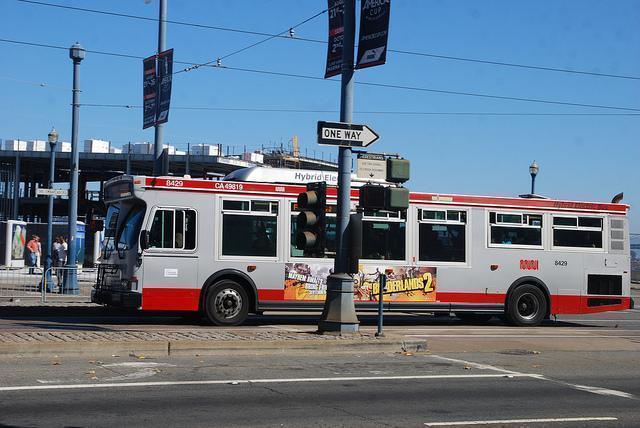What type of company paid to have their product advertised on the bus?
Select the correct answer and articulate reasoning with the following format: 'Answer: answer
Rationale: rationale.'
Options: Travel, movie, video game, food. Answer: video game.
Rationale: Looks like a new game coming out that is on the side of the bus. 